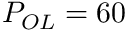Convert formula to latex. <formula><loc_0><loc_0><loc_500><loc_500>P _ { O L } = 6 0 \</formula> 